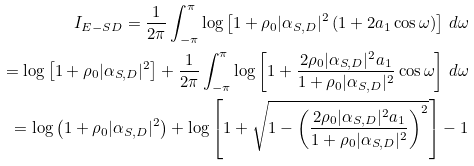Convert formula to latex. <formula><loc_0><loc_0><loc_500><loc_500>I _ { E - S D } = \frac { 1 } { 2 \pi } \int _ { - \pi } ^ { \pi } \log \left [ 1 + \rho _ { 0 } | \alpha _ { S , D } | ^ { 2 } \left ( 1 + 2 a _ { 1 } \cos \omega \right ) \right ] \, d \omega \\ = \log \left [ 1 + \rho _ { 0 } | \alpha _ { S , D } | ^ { 2 } \right ] + \frac { 1 } { 2 \pi } \int _ { - \pi } ^ { \pi } \log \left [ 1 + \frac { 2 \rho _ { 0 } | \alpha _ { S , D } | ^ { 2 } a _ { 1 } } { 1 + \rho _ { 0 } | \alpha _ { S , D } | ^ { 2 } } \cos \omega \right ] \, d \omega \\ = \log \left ( 1 + \rho _ { 0 } | \alpha _ { S , D } | ^ { 2 } \right ) + \log \left [ { 1 + \sqrt { 1 - \left ( \frac { 2 \rho _ { 0 } | \alpha _ { S , D } | ^ { 2 } a _ { 1 } } { 1 + \rho _ { 0 } | \alpha _ { S , D } | ^ { 2 } } \right ) ^ { 2 } } } \right ] - 1</formula> 